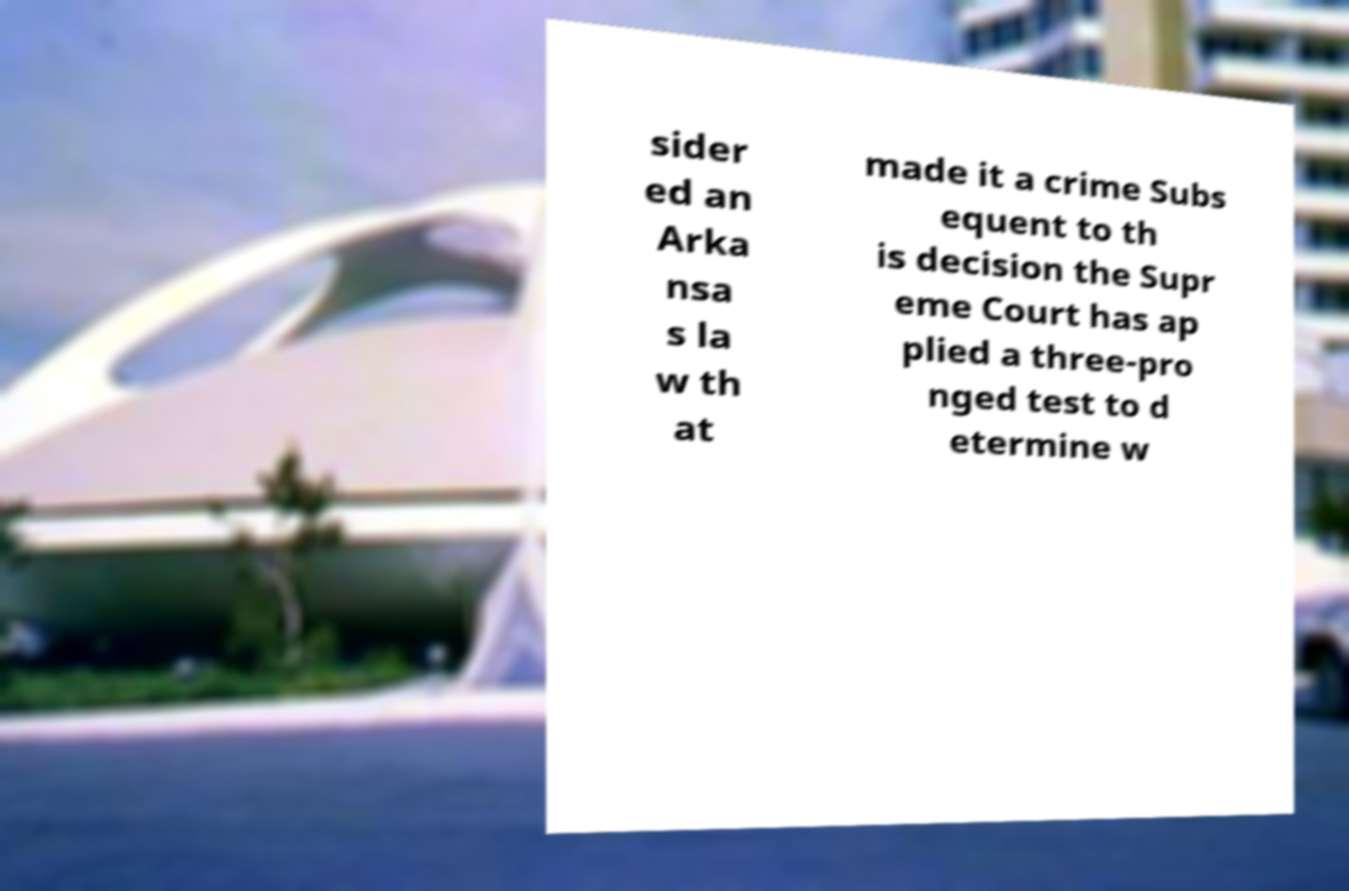For documentation purposes, I need the text within this image transcribed. Could you provide that? sider ed an Arka nsa s la w th at made it a crime Subs equent to th is decision the Supr eme Court has ap plied a three-pro nged test to d etermine w 